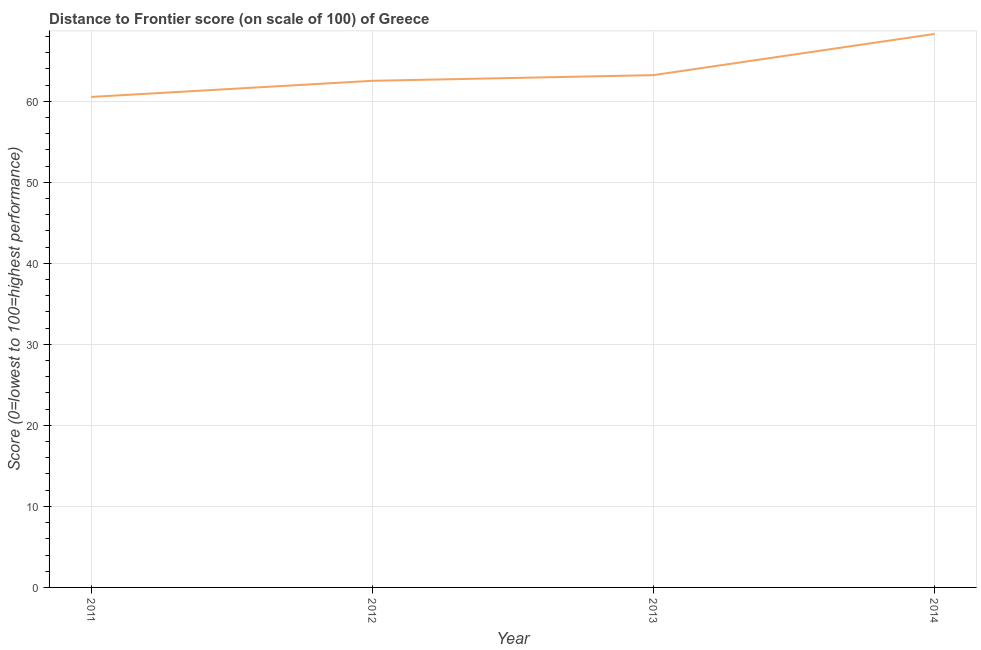What is the distance to frontier score in 2014?
Keep it short and to the point. 68.3. Across all years, what is the maximum distance to frontier score?
Your answer should be compact. 68.3. Across all years, what is the minimum distance to frontier score?
Offer a very short reply. 60.53. In which year was the distance to frontier score minimum?
Provide a succinct answer. 2011. What is the sum of the distance to frontier score?
Ensure brevity in your answer.  254.57. What is the difference between the distance to frontier score in 2012 and 2014?
Offer a terse response. -5.78. What is the average distance to frontier score per year?
Ensure brevity in your answer.  63.64. What is the median distance to frontier score?
Ensure brevity in your answer.  62.87. In how many years, is the distance to frontier score greater than 14 ?
Your answer should be very brief. 4. Do a majority of the years between 2013 and 2014 (inclusive) have distance to frontier score greater than 6 ?
Offer a terse response. Yes. What is the ratio of the distance to frontier score in 2013 to that in 2014?
Provide a short and direct response. 0.93. Is the distance to frontier score in 2013 less than that in 2014?
Ensure brevity in your answer.  Yes. What is the difference between the highest and the second highest distance to frontier score?
Offer a terse response. 5.08. What is the difference between the highest and the lowest distance to frontier score?
Offer a terse response. 7.77. In how many years, is the distance to frontier score greater than the average distance to frontier score taken over all years?
Your answer should be compact. 1. Does the distance to frontier score monotonically increase over the years?
Offer a terse response. Yes. How many lines are there?
Provide a short and direct response. 1. What is the difference between two consecutive major ticks on the Y-axis?
Provide a succinct answer. 10. Does the graph contain grids?
Provide a succinct answer. Yes. What is the title of the graph?
Ensure brevity in your answer.  Distance to Frontier score (on scale of 100) of Greece. What is the label or title of the X-axis?
Ensure brevity in your answer.  Year. What is the label or title of the Y-axis?
Give a very brief answer. Score (0=lowest to 100=highest performance). What is the Score (0=lowest to 100=highest performance) of 2011?
Keep it short and to the point. 60.53. What is the Score (0=lowest to 100=highest performance) in 2012?
Provide a succinct answer. 62.52. What is the Score (0=lowest to 100=highest performance) of 2013?
Offer a very short reply. 63.22. What is the Score (0=lowest to 100=highest performance) in 2014?
Your response must be concise. 68.3. What is the difference between the Score (0=lowest to 100=highest performance) in 2011 and 2012?
Provide a short and direct response. -1.99. What is the difference between the Score (0=lowest to 100=highest performance) in 2011 and 2013?
Give a very brief answer. -2.69. What is the difference between the Score (0=lowest to 100=highest performance) in 2011 and 2014?
Provide a short and direct response. -7.77. What is the difference between the Score (0=lowest to 100=highest performance) in 2012 and 2013?
Offer a very short reply. -0.7. What is the difference between the Score (0=lowest to 100=highest performance) in 2012 and 2014?
Ensure brevity in your answer.  -5.78. What is the difference between the Score (0=lowest to 100=highest performance) in 2013 and 2014?
Keep it short and to the point. -5.08. What is the ratio of the Score (0=lowest to 100=highest performance) in 2011 to that in 2012?
Your response must be concise. 0.97. What is the ratio of the Score (0=lowest to 100=highest performance) in 2011 to that in 2014?
Offer a very short reply. 0.89. What is the ratio of the Score (0=lowest to 100=highest performance) in 2012 to that in 2013?
Give a very brief answer. 0.99. What is the ratio of the Score (0=lowest to 100=highest performance) in 2012 to that in 2014?
Your answer should be compact. 0.92. What is the ratio of the Score (0=lowest to 100=highest performance) in 2013 to that in 2014?
Offer a very short reply. 0.93. 